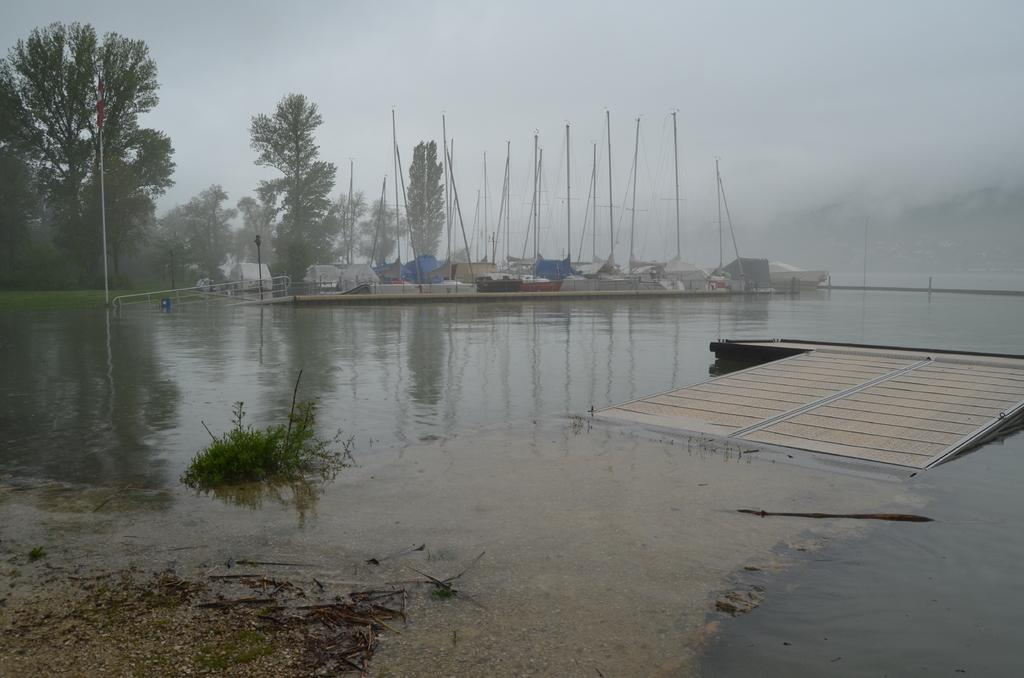What is visible in the image? Water is visible in the image. What can be seen in the background of the image? There are tents, poles, and trees in the background of the image. What type of smoke can be seen coming from the gun in the image? There is no gun or smoke present in the image. 